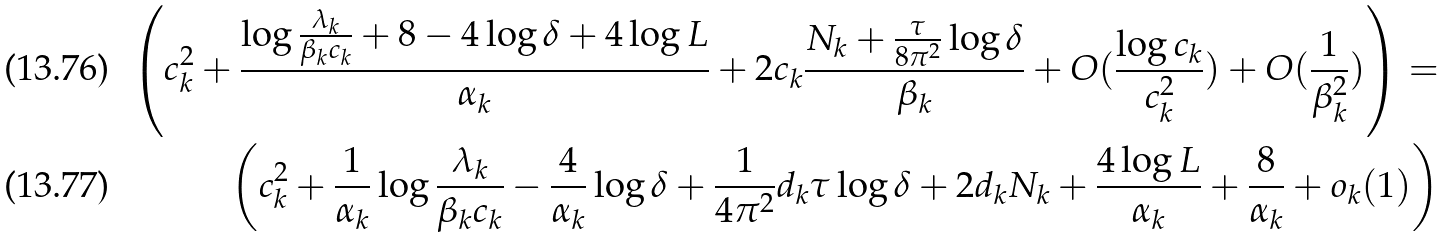<formula> <loc_0><loc_0><loc_500><loc_500>\left ( c _ { k } ^ { 2 } + \frac { \log \frac { \lambda _ { k } } { \beta _ { k } c _ { k } } + 8 - 4 \log \delta + 4 \log L } { \alpha _ { k } } + 2 c _ { k } \frac { N _ { k } + \frac { \tau } { 8 \pi ^ { 2 } } \log \delta } { \beta _ { k } } + O ( \frac { \log c _ { k } } { c _ { k } ^ { 2 } } ) + O ( \frac { 1 } { \beta _ { k } ^ { 2 } } ) \right ) = \\ \left ( c _ { k } ^ { 2 } + \frac { 1 } { \alpha _ { k } } \log \frac { \lambda _ { k } } { \beta _ { k } c _ { k } } - \frac { 4 } { \alpha _ { k } } \log \delta + \frac { 1 } { 4 \pi ^ { 2 } } d _ { k } \tau \log \delta + 2 d _ { k } N _ { k } + \frac { 4 \log L } { \alpha _ { k } } + \frac { 8 } { \alpha _ { k } } + o _ { k } ( 1 ) \right )</formula> 